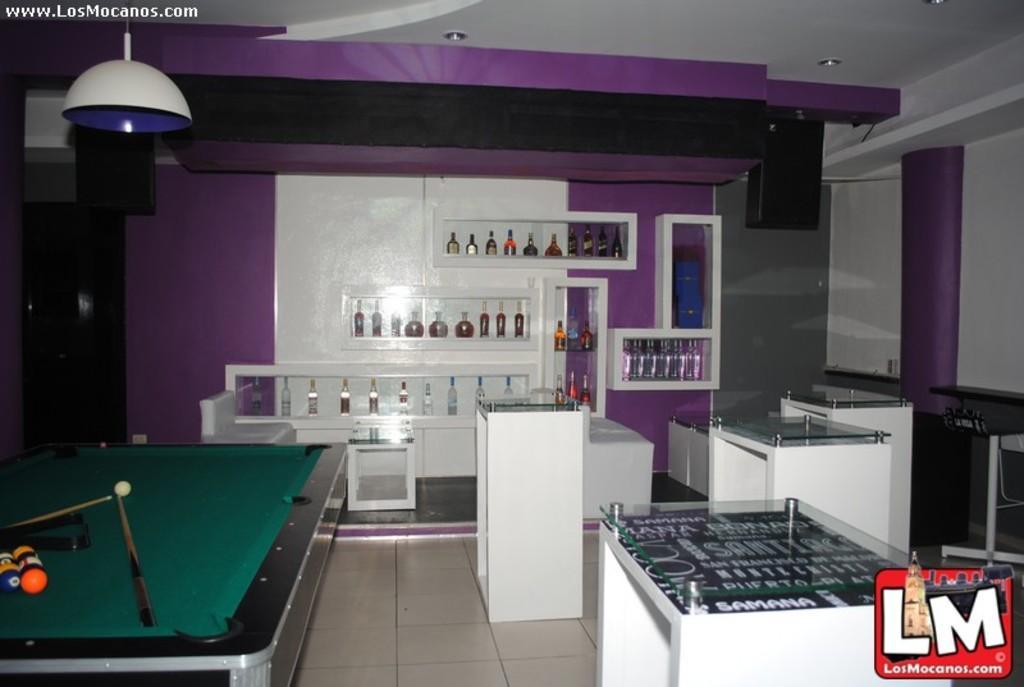Could you give a brief overview of what you see in this image? In the picture we can see a house, in that house we can see a snookers board with balls and stick, and just beside to it there is another game which is on table and background we can see a bottles placed in racks which are with wine, to the ceiling there is a light. 